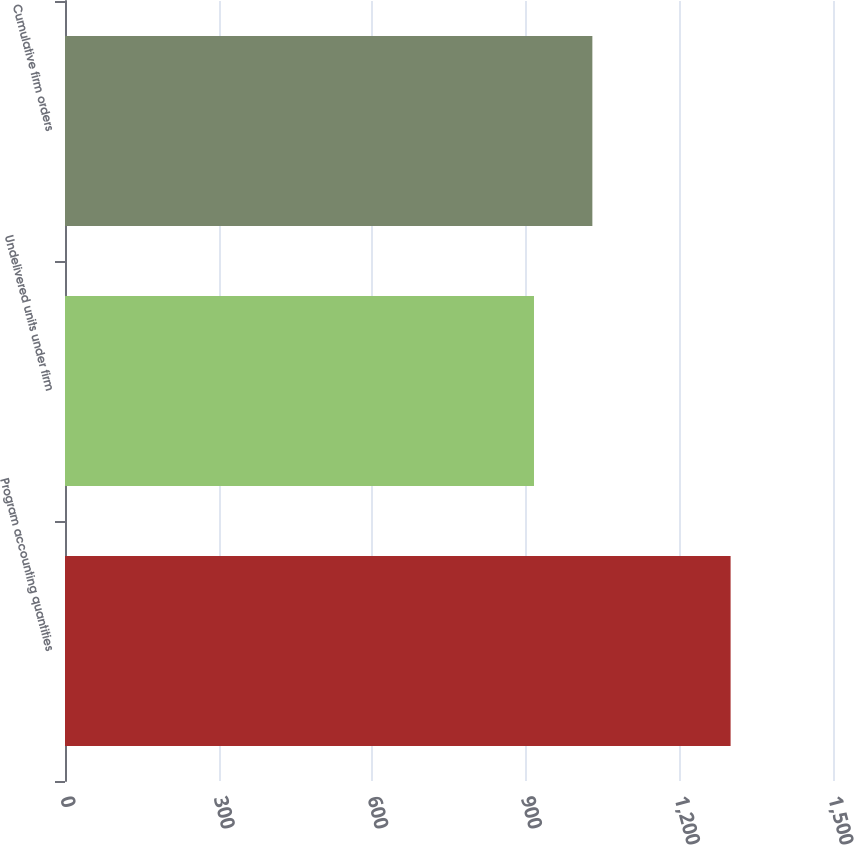Convert chart. <chart><loc_0><loc_0><loc_500><loc_500><bar_chart><fcel>Program accounting quantities<fcel>Undelivered units under firm<fcel>Cumulative firm orders<nl><fcel>1300<fcel>916<fcel>1030<nl></chart> 